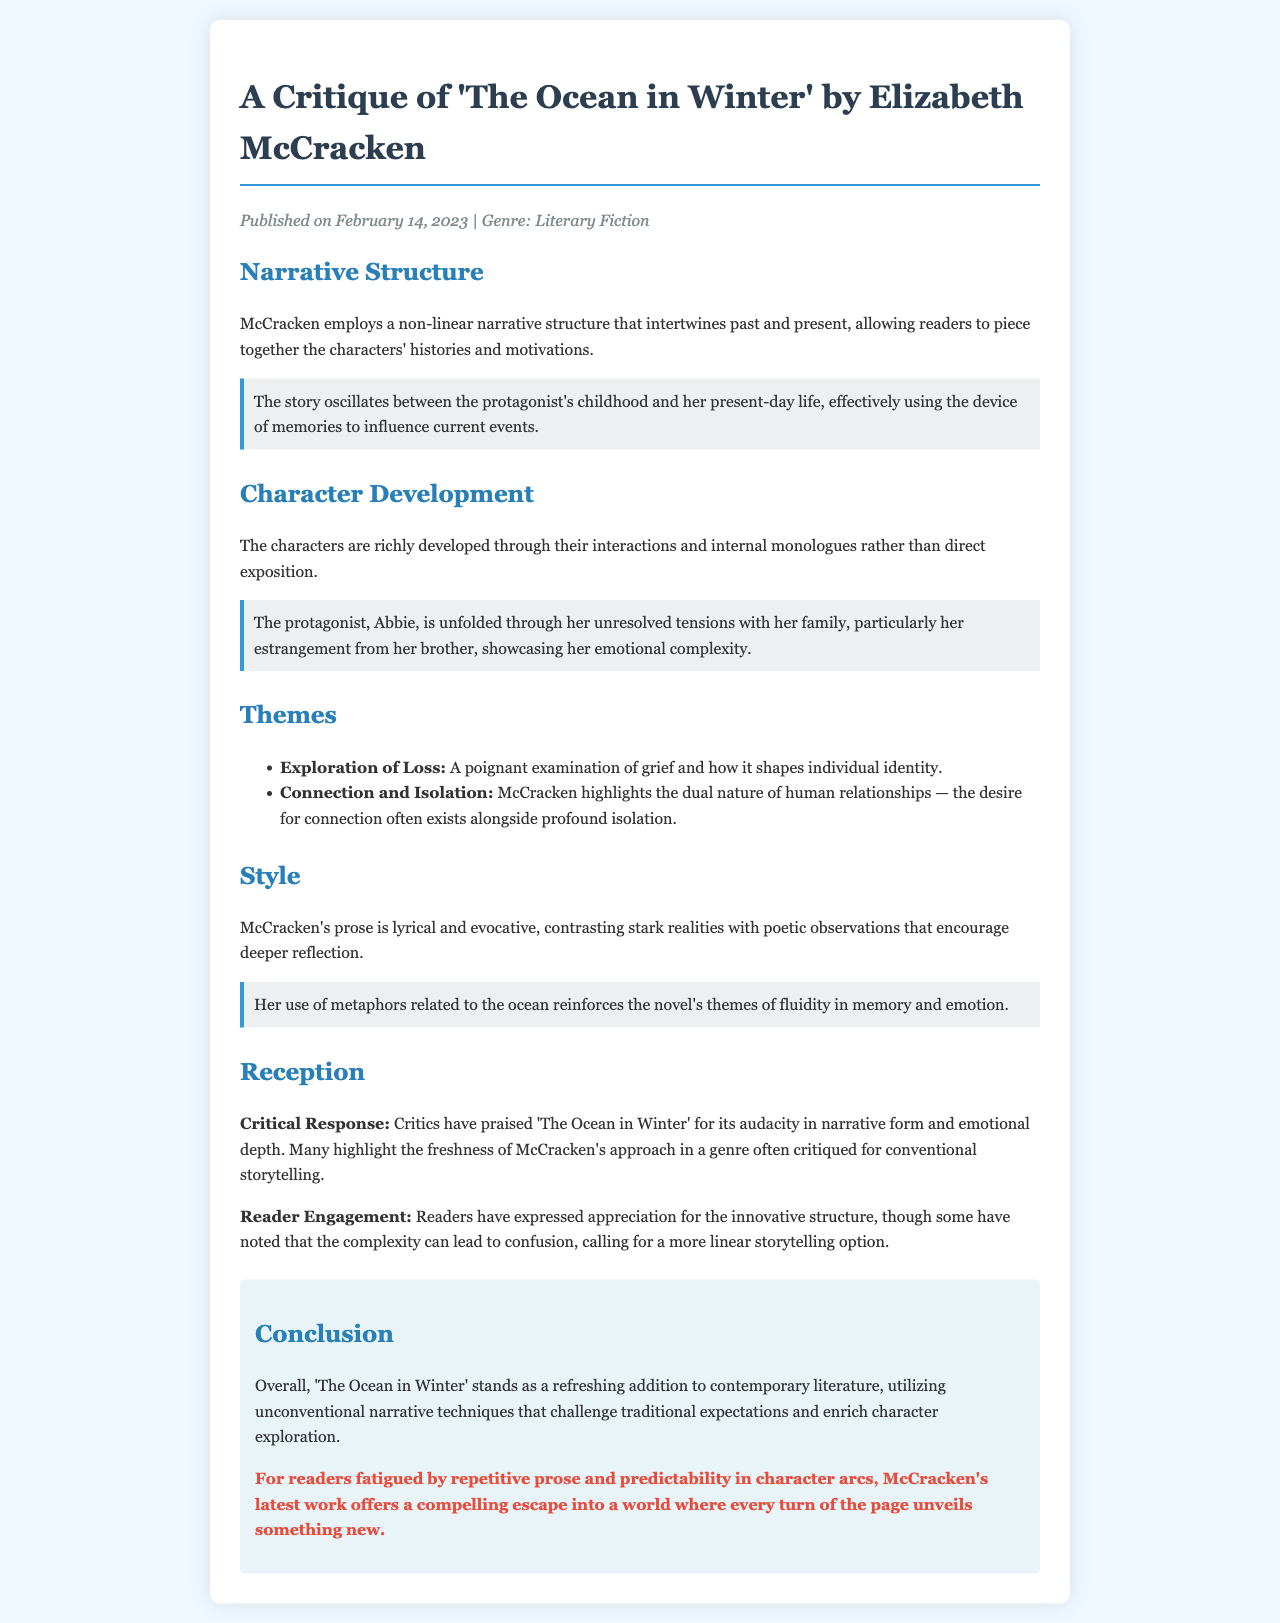What is the title of the novel critiqued? The title of the novel critiqued is stated at the beginning of the document.
Answer: The Ocean in Winter Who is the author of the novel? The author's name is provided in the title section of the critique.
Answer: Elizabeth McCracken When was the novel published? The publication date is mentioned in the meta section of the document.
Answer: February 14, 2023 What narrative structure does McCracken use? The narrative structure is described in the section about narrative structure of the critique.
Answer: Non-linear What is the protagonist's name? The protagonist's name is mentioned in the character development section of the critique.
Answer: Abbie What theme involves human relationships? One of the themes is listed in the themes section of the document.
Answer: Connection and Isolation How is McCracken's prose described? The style section contains an overview of how her prose is characterized.
Answer: Lyrical and evocative What have critics praised about the novel? The critical response section highlights specific praises for the book.
Answer: Audacity in narrative form What do some readers find confusing? The reader engagement section discusses reader reactions toward the book.
Answer: Complexity of the structure 